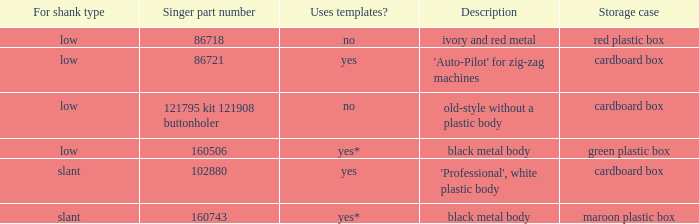What's the specification of the buttonholer with singer part number 121795 kit 121908 buttonholer? Old-style without a plastic body. 